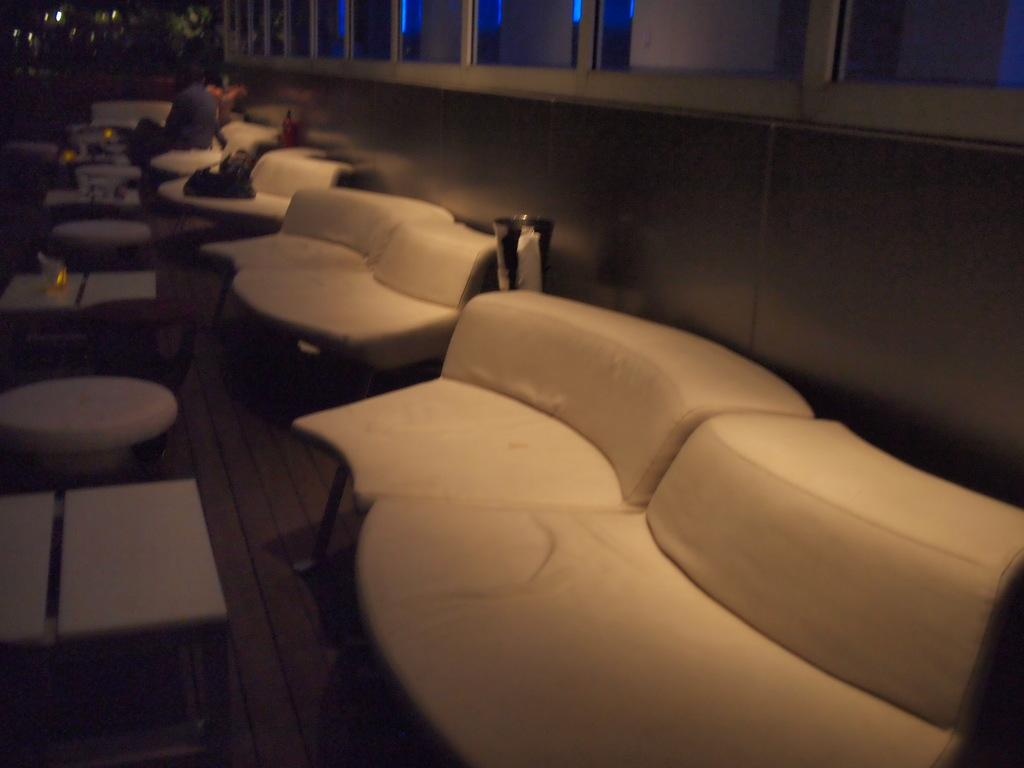What type of furniture is present in large numbers in the image? There are many white chairs in the image. What other objects can be seen in the image besides the chairs? Tables are visible in the image. What are the people in the image doing? Two persons are sitting on a chair. What is placed on the tables in the image? Candles are kept on the table. What can be seen in the background of the image? There are some lights in the background. What rhythm is the hand clapping in the image? There is no hand clapping or rhythm present in the image. 